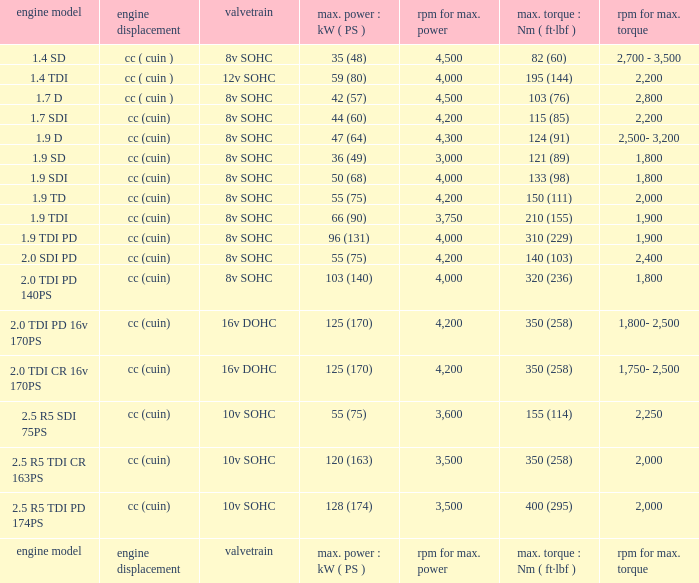What is the valvetrain with an engine model that is engine model? Valvetrain. 